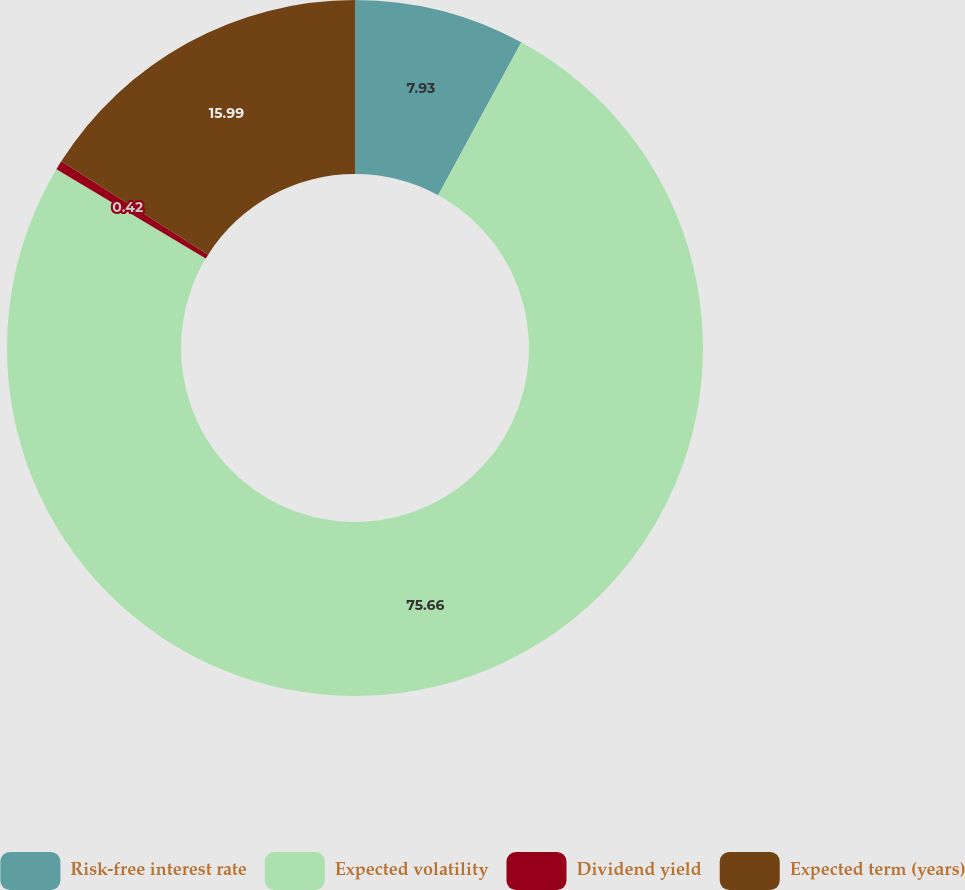Convert chart. <chart><loc_0><loc_0><loc_500><loc_500><pie_chart><fcel>Risk-free interest rate<fcel>Expected volatility<fcel>Dividend yield<fcel>Expected term (years)<nl><fcel>7.93%<fcel>75.66%<fcel>0.42%<fcel>15.99%<nl></chart> 